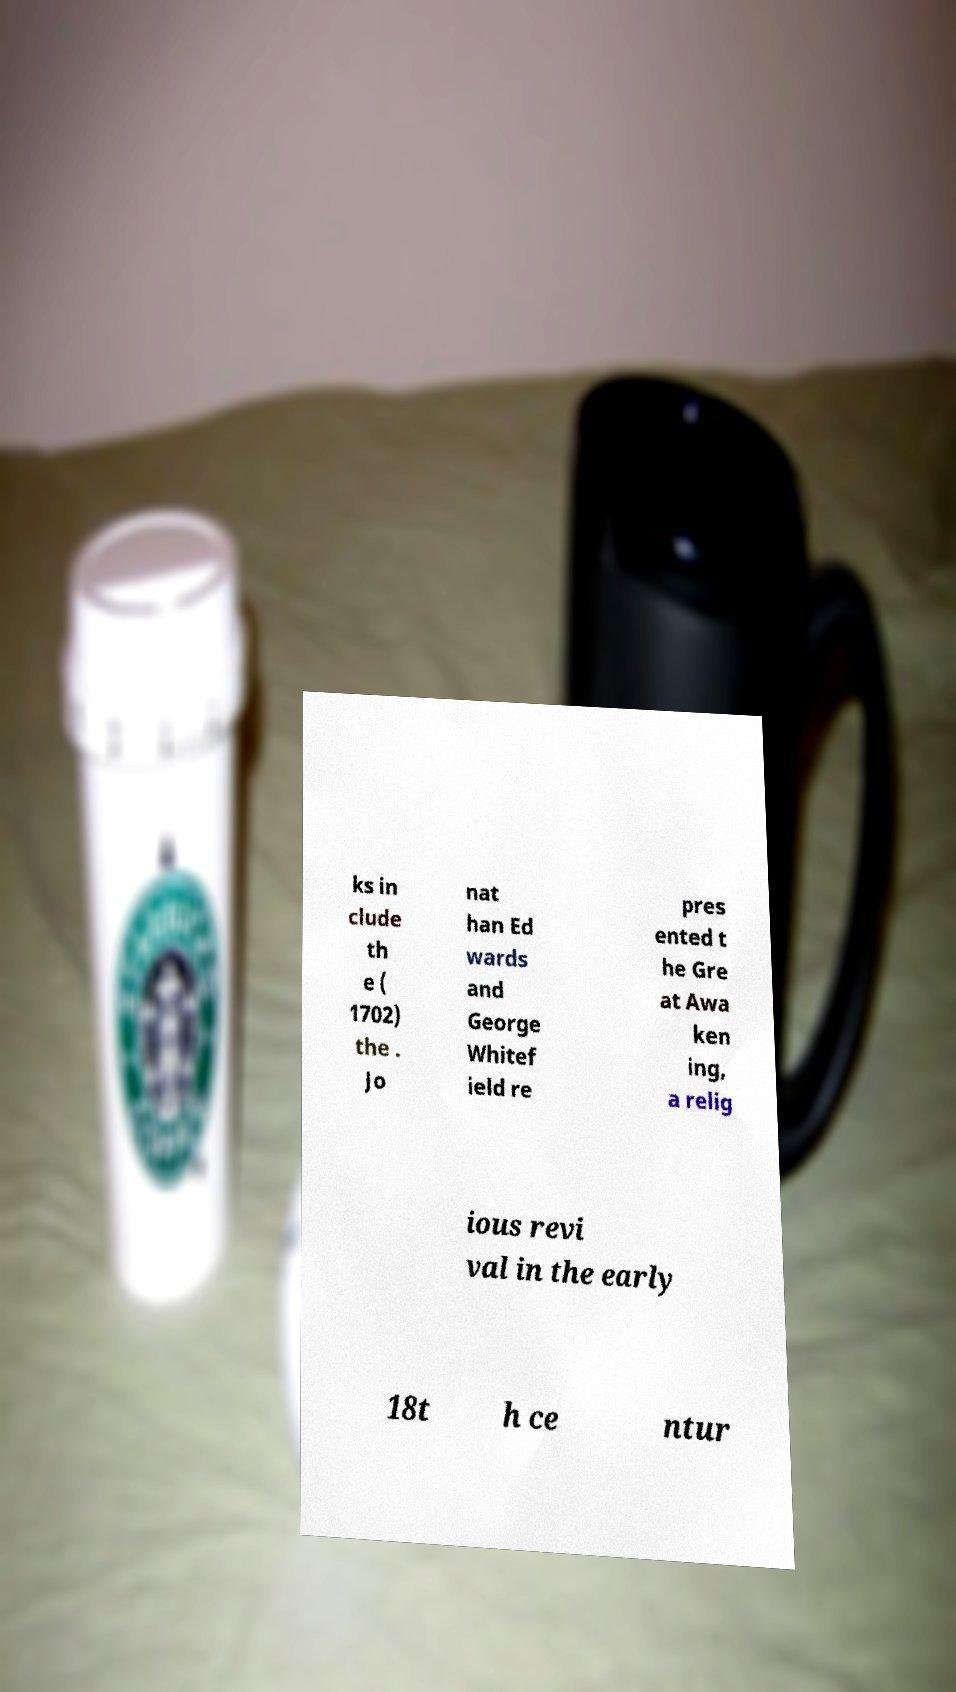For documentation purposes, I need the text within this image transcribed. Could you provide that? ks in clude th e ( 1702) the . Jo nat han Ed wards and George Whitef ield re pres ented t he Gre at Awa ken ing, a relig ious revi val in the early 18t h ce ntur 